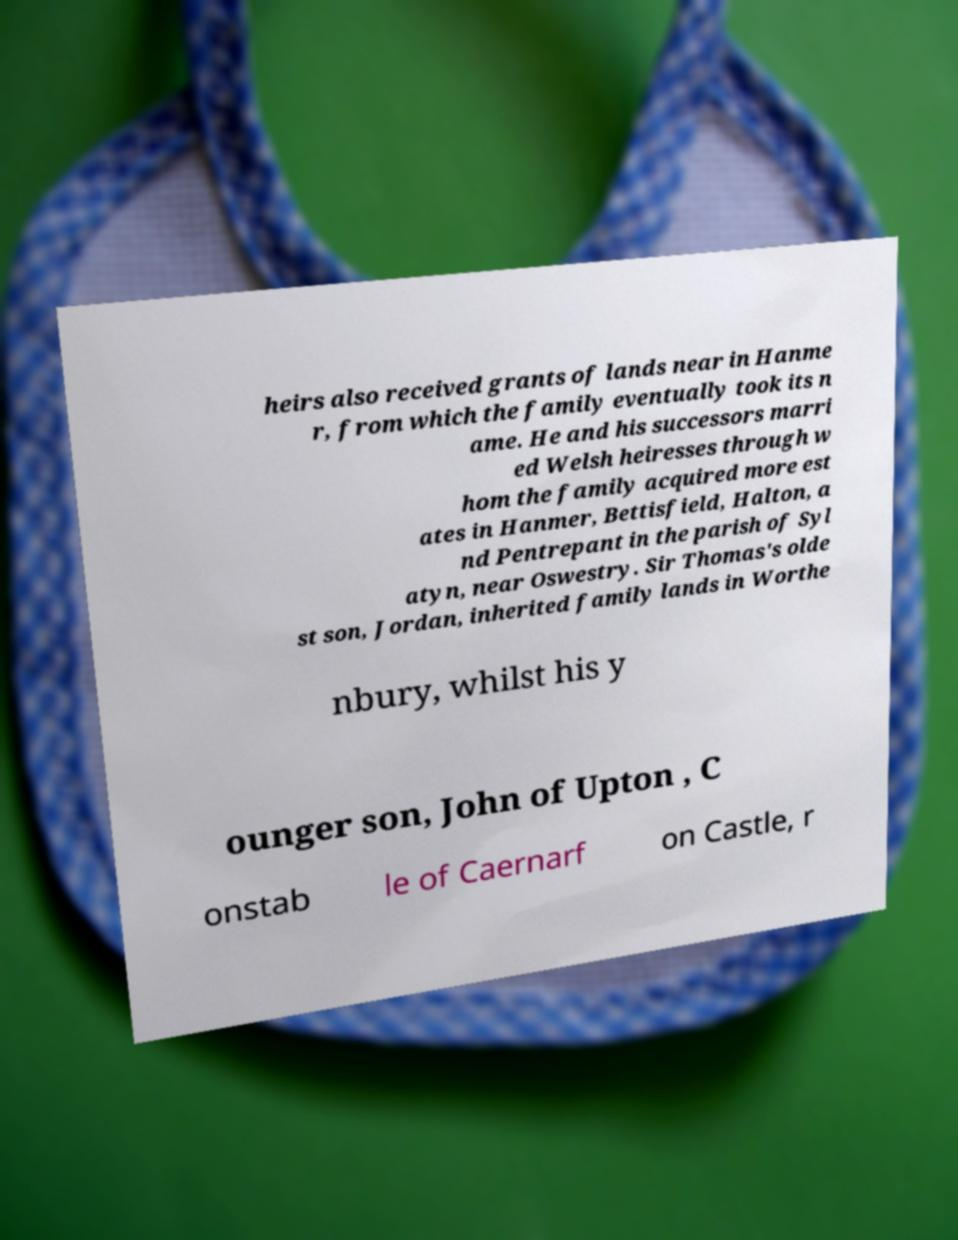For documentation purposes, I need the text within this image transcribed. Could you provide that? heirs also received grants of lands near in Hanme r, from which the family eventually took its n ame. He and his successors marri ed Welsh heiresses through w hom the family acquired more est ates in Hanmer, Bettisfield, Halton, a nd Pentrepant in the parish of Syl atyn, near Oswestry. Sir Thomas's olde st son, Jordan, inherited family lands in Worthe nbury, whilst his y ounger son, John of Upton , C onstab le of Caernarf on Castle, r 